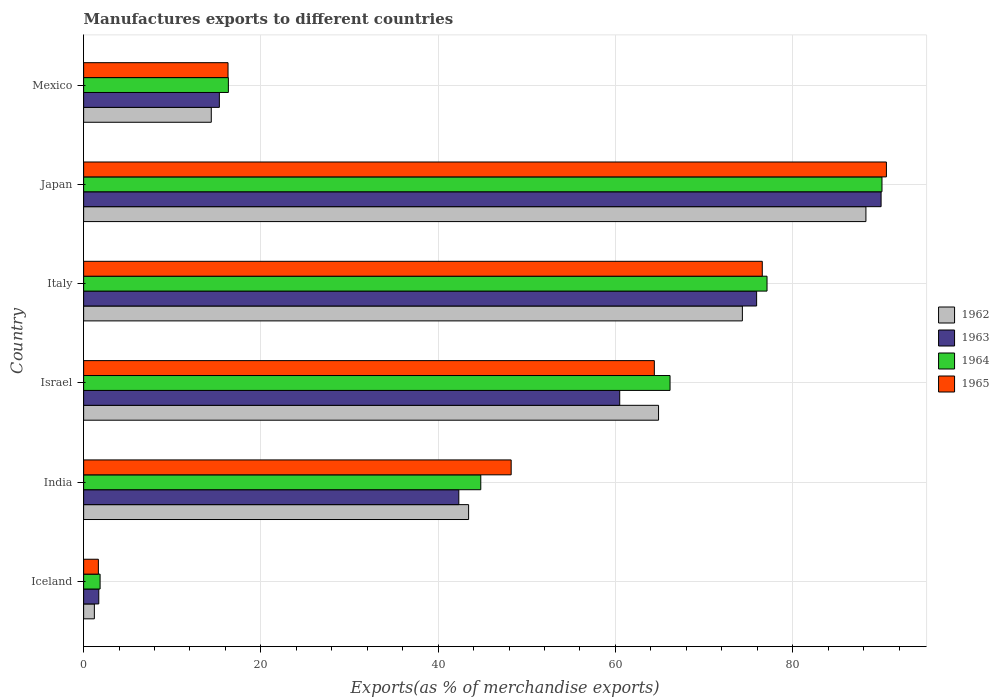How many bars are there on the 6th tick from the top?
Offer a very short reply. 4. How many bars are there on the 4th tick from the bottom?
Keep it short and to the point. 4. What is the label of the 4th group of bars from the top?
Your response must be concise. Israel. What is the percentage of exports to different countries in 1962 in Mexico?
Make the answer very short. 14.4. Across all countries, what is the maximum percentage of exports to different countries in 1964?
Give a very brief answer. 90.07. Across all countries, what is the minimum percentage of exports to different countries in 1962?
Keep it short and to the point. 1.21. In which country was the percentage of exports to different countries in 1962 maximum?
Offer a very short reply. Japan. In which country was the percentage of exports to different countries in 1965 minimum?
Your response must be concise. Iceland. What is the total percentage of exports to different countries in 1963 in the graph?
Make the answer very short. 285.74. What is the difference between the percentage of exports to different countries in 1962 in India and that in Israel?
Provide a succinct answer. -21.43. What is the difference between the percentage of exports to different countries in 1965 in Iceland and the percentage of exports to different countries in 1964 in Israel?
Offer a terse response. -64.5. What is the average percentage of exports to different countries in 1962 per country?
Offer a very short reply. 47.75. What is the difference between the percentage of exports to different countries in 1963 and percentage of exports to different countries in 1965 in Mexico?
Keep it short and to the point. -0.98. In how many countries, is the percentage of exports to different countries in 1964 greater than 44 %?
Your answer should be compact. 4. What is the ratio of the percentage of exports to different countries in 1963 in Italy to that in Japan?
Your response must be concise. 0.84. Is the percentage of exports to different countries in 1963 in Israel less than that in Italy?
Offer a very short reply. Yes. What is the difference between the highest and the second highest percentage of exports to different countries in 1962?
Provide a succinct answer. 13.94. What is the difference between the highest and the lowest percentage of exports to different countries in 1965?
Give a very brief answer. 88.91. In how many countries, is the percentage of exports to different countries in 1962 greater than the average percentage of exports to different countries in 1962 taken over all countries?
Ensure brevity in your answer.  3. What does the 3rd bar from the top in India represents?
Give a very brief answer. 1963. What does the 1st bar from the bottom in India represents?
Your response must be concise. 1962. Is it the case that in every country, the sum of the percentage of exports to different countries in 1965 and percentage of exports to different countries in 1964 is greater than the percentage of exports to different countries in 1962?
Your answer should be very brief. Yes. Are all the bars in the graph horizontal?
Provide a succinct answer. Yes. How many countries are there in the graph?
Provide a short and direct response. 6. What is the title of the graph?
Your response must be concise. Manufactures exports to different countries. Does "1964" appear as one of the legend labels in the graph?
Give a very brief answer. Yes. What is the label or title of the X-axis?
Provide a short and direct response. Exports(as % of merchandise exports). What is the label or title of the Y-axis?
Offer a very short reply. Country. What is the Exports(as % of merchandise exports) in 1962 in Iceland?
Give a very brief answer. 1.21. What is the Exports(as % of merchandise exports) in 1963 in Iceland?
Your answer should be very brief. 1.71. What is the Exports(as % of merchandise exports) of 1964 in Iceland?
Your answer should be compact. 1.86. What is the Exports(as % of merchandise exports) of 1965 in Iceland?
Offer a terse response. 1.66. What is the Exports(as % of merchandise exports) of 1962 in India?
Make the answer very short. 43.43. What is the Exports(as % of merchandise exports) in 1963 in India?
Give a very brief answer. 42.33. What is the Exports(as % of merchandise exports) of 1964 in India?
Make the answer very short. 44.81. What is the Exports(as % of merchandise exports) of 1965 in India?
Provide a succinct answer. 48.24. What is the Exports(as % of merchandise exports) in 1962 in Israel?
Provide a succinct answer. 64.86. What is the Exports(as % of merchandise exports) of 1963 in Israel?
Provide a short and direct response. 60.48. What is the Exports(as % of merchandise exports) of 1964 in Israel?
Make the answer very short. 66.16. What is the Exports(as % of merchandise exports) of 1965 in Israel?
Your answer should be very brief. 64.39. What is the Exports(as % of merchandise exports) in 1962 in Italy?
Your answer should be very brief. 74.32. What is the Exports(as % of merchandise exports) of 1963 in Italy?
Offer a very short reply. 75.93. What is the Exports(as % of merchandise exports) in 1964 in Italy?
Your response must be concise. 77.1. What is the Exports(as % of merchandise exports) of 1965 in Italy?
Your answer should be very brief. 76.57. What is the Exports(as % of merchandise exports) in 1962 in Japan?
Offer a terse response. 88.26. What is the Exports(as % of merchandise exports) of 1963 in Japan?
Provide a succinct answer. 89.97. What is the Exports(as % of merchandise exports) in 1964 in Japan?
Give a very brief answer. 90.07. What is the Exports(as % of merchandise exports) in 1965 in Japan?
Make the answer very short. 90.57. What is the Exports(as % of merchandise exports) in 1962 in Mexico?
Ensure brevity in your answer.  14.4. What is the Exports(as % of merchandise exports) in 1963 in Mexico?
Ensure brevity in your answer.  15.31. What is the Exports(as % of merchandise exports) in 1964 in Mexico?
Ensure brevity in your answer.  16.33. What is the Exports(as % of merchandise exports) in 1965 in Mexico?
Provide a succinct answer. 16.29. Across all countries, what is the maximum Exports(as % of merchandise exports) of 1962?
Your response must be concise. 88.26. Across all countries, what is the maximum Exports(as % of merchandise exports) in 1963?
Your response must be concise. 89.97. Across all countries, what is the maximum Exports(as % of merchandise exports) of 1964?
Give a very brief answer. 90.07. Across all countries, what is the maximum Exports(as % of merchandise exports) of 1965?
Keep it short and to the point. 90.57. Across all countries, what is the minimum Exports(as % of merchandise exports) of 1962?
Offer a very short reply. 1.21. Across all countries, what is the minimum Exports(as % of merchandise exports) in 1963?
Provide a succinct answer. 1.71. Across all countries, what is the minimum Exports(as % of merchandise exports) of 1964?
Make the answer very short. 1.86. Across all countries, what is the minimum Exports(as % of merchandise exports) in 1965?
Your answer should be compact. 1.66. What is the total Exports(as % of merchandise exports) of 1962 in the graph?
Your answer should be compact. 286.49. What is the total Exports(as % of merchandise exports) in 1963 in the graph?
Provide a short and direct response. 285.74. What is the total Exports(as % of merchandise exports) in 1964 in the graph?
Give a very brief answer. 296.33. What is the total Exports(as % of merchandise exports) of 1965 in the graph?
Your response must be concise. 297.72. What is the difference between the Exports(as % of merchandise exports) in 1962 in Iceland and that in India?
Keep it short and to the point. -42.22. What is the difference between the Exports(as % of merchandise exports) in 1963 in Iceland and that in India?
Your answer should be compact. -40.62. What is the difference between the Exports(as % of merchandise exports) in 1964 in Iceland and that in India?
Offer a very short reply. -42.95. What is the difference between the Exports(as % of merchandise exports) of 1965 in Iceland and that in India?
Your answer should be compact. -46.57. What is the difference between the Exports(as % of merchandise exports) of 1962 in Iceland and that in Israel?
Your response must be concise. -63.65. What is the difference between the Exports(as % of merchandise exports) in 1963 in Iceland and that in Israel?
Keep it short and to the point. -58.77. What is the difference between the Exports(as % of merchandise exports) of 1964 in Iceland and that in Israel?
Make the answer very short. -64.3. What is the difference between the Exports(as % of merchandise exports) in 1965 in Iceland and that in Israel?
Give a very brief answer. -62.73. What is the difference between the Exports(as % of merchandise exports) in 1962 in Iceland and that in Italy?
Offer a very short reply. -73.11. What is the difference between the Exports(as % of merchandise exports) in 1963 in Iceland and that in Italy?
Offer a terse response. -74.22. What is the difference between the Exports(as % of merchandise exports) of 1964 in Iceland and that in Italy?
Offer a terse response. -75.25. What is the difference between the Exports(as % of merchandise exports) of 1965 in Iceland and that in Italy?
Keep it short and to the point. -74.9. What is the difference between the Exports(as % of merchandise exports) of 1962 in Iceland and that in Japan?
Give a very brief answer. -87.05. What is the difference between the Exports(as % of merchandise exports) in 1963 in Iceland and that in Japan?
Give a very brief answer. -88.26. What is the difference between the Exports(as % of merchandise exports) in 1964 in Iceland and that in Japan?
Your answer should be very brief. -88.22. What is the difference between the Exports(as % of merchandise exports) of 1965 in Iceland and that in Japan?
Offer a terse response. -88.91. What is the difference between the Exports(as % of merchandise exports) in 1962 in Iceland and that in Mexico?
Keep it short and to the point. -13.19. What is the difference between the Exports(as % of merchandise exports) in 1963 in Iceland and that in Mexico?
Ensure brevity in your answer.  -13.6. What is the difference between the Exports(as % of merchandise exports) of 1964 in Iceland and that in Mexico?
Give a very brief answer. -14.47. What is the difference between the Exports(as % of merchandise exports) in 1965 in Iceland and that in Mexico?
Make the answer very short. -14.63. What is the difference between the Exports(as % of merchandise exports) in 1962 in India and that in Israel?
Your response must be concise. -21.43. What is the difference between the Exports(as % of merchandise exports) in 1963 in India and that in Israel?
Your answer should be very brief. -18.15. What is the difference between the Exports(as % of merchandise exports) in 1964 in India and that in Israel?
Make the answer very short. -21.35. What is the difference between the Exports(as % of merchandise exports) in 1965 in India and that in Israel?
Your answer should be compact. -16.15. What is the difference between the Exports(as % of merchandise exports) in 1962 in India and that in Italy?
Ensure brevity in your answer.  -30.89. What is the difference between the Exports(as % of merchandise exports) in 1963 in India and that in Italy?
Make the answer very short. -33.6. What is the difference between the Exports(as % of merchandise exports) of 1964 in India and that in Italy?
Your answer should be compact. -32.3. What is the difference between the Exports(as % of merchandise exports) of 1965 in India and that in Italy?
Give a very brief answer. -28.33. What is the difference between the Exports(as % of merchandise exports) in 1962 in India and that in Japan?
Your answer should be compact. -44.83. What is the difference between the Exports(as % of merchandise exports) of 1963 in India and that in Japan?
Give a very brief answer. -47.64. What is the difference between the Exports(as % of merchandise exports) of 1964 in India and that in Japan?
Give a very brief answer. -45.26. What is the difference between the Exports(as % of merchandise exports) in 1965 in India and that in Japan?
Keep it short and to the point. -42.34. What is the difference between the Exports(as % of merchandise exports) in 1962 in India and that in Mexico?
Give a very brief answer. 29.03. What is the difference between the Exports(as % of merchandise exports) of 1963 in India and that in Mexico?
Offer a very short reply. 27.01. What is the difference between the Exports(as % of merchandise exports) in 1964 in India and that in Mexico?
Make the answer very short. 28.48. What is the difference between the Exports(as % of merchandise exports) in 1965 in India and that in Mexico?
Keep it short and to the point. 31.95. What is the difference between the Exports(as % of merchandise exports) in 1962 in Israel and that in Italy?
Your answer should be compact. -9.46. What is the difference between the Exports(as % of merchandise exports) of 1963 in Israel and that in Italy?
Keep it short and to the point. -15.45. What is the difference between the Exports(as % of merchandise exports) of 1964 in Israel and that in Italy?
Keep it short and to the point. -10.94. What is the difference between the Exports(as % of merchandise exports) in 1965 in Israel and that in Italy?
Give a very brief answer. -12.18. What is the difference between the Exports(as % of merchandise exports) in 1962 in Israel and that in Japan?
Your answer should be compact. -23.4. What is the difference between the Exports(as % of merchandise exports) of 1963 in Israel and that in Japan?
Ensure brevity in your answer.  -29.49. What is the difference between the Exports(as % of merchandise exports) of 1964 in Israel and that in Japan?
Provide a succinct answer. -23.91. What is the difference between the Exports(as % of merchandise exports) in 1965 in Israel and that in Japan?
Make the answer very short. -26.18. What is the difference between the Exports(as % of merchandise exports) in 1962 in Israel and that in Mexico?
Keep it short and to the point. 50.46. What is the difference between the Exports(as % of merchandise exports) of 1963 in Israel and that in Mexico?
Give a very brief answer. 45.17. What is the difference between the Exports(as % of merchandise exports) of 1964 in Israel and that in Mexico?
Your answer should be compact. 49.83. What is the difference between the Exports(as % of merchandise exports) of 1965 in Israel and that in Mexico?
Ensure brevity in your answer.  48.1. What is the difference between the Exports(as % of merchandise exports) of 1962 in Italy and that in Japan?
Your answer should be very brief. -13.94. What is the difference between the Exports(as % of merchandise exports) of 1963 in Italy and that in Japan?
Give a very brief answer. -14.04. What is the difference between the Exports(as % of merchandise exports) in 1964 in Italy and that in Japan?
Provide a short and direct response. -12.97. What is the difference between the Exports(as % of merchandise exports) in 1965 in Italy and that in Japan?
Your answer should be very brief. -14.01. What is the difference between the Exports(as % of merchandise exports) in 1962 in Italy and that in Mexico?
Offer a very short reply. 59.92. What is the difference between the Exports(as % of merchandise exports) of 1963 in Italy and that in Mexico?
Your response must be concise. 60.61. What is the difference between the Exports(as % of merchandise exports) in 1964 in Italy and that in Mexico?
Your response must be concise. 60.77. What is the difference between the Exports(as % of merchandise exports) in 1965 in Italy and that in Mexico?
Provide a succinct answer. 60.28. What is the difference between the Exports(as % of merchandise exports) in 1962 in Japan and that in Mexico?
Your response must be concise. 73.86. What is the difference between the Exports(as % of merchandise exports) of 1963 in Japan and that in Mexico?
Your response must be concise. 74.66. What is the difference between the Exports(as % of merchandise exports) of 1964 in Japan and that in Mexico?
Offer a very short reply. 73.74. What is the difference between the Exports(as % of merchandise exports) of 1965 in Japan and that in Mexico?
Your response must be concise. 74.28. What is the difference between the Exports(as % of merchandise exports) in 1962 in Iceland and the Exports(as % of merchandise exports) in 1963 in India?
Offer a very short reply. -41.12. What is the difference between the Exports(as % of merchandise exports) in 1962 in Iceland and the Exports(as % of merchandise exports) in 1964 in India?
Offer a terse response. -43.6. What is the difference between the Exports(as % of merchandise exports) of 1962 in Iceland and the Exports(as % of merchandise exports) of 1965 in India?
Provide a short and direct response. -47.03. What is the difference between the Exports(as % of merchandise exports) of 1963 in Iceland and the Exports(as % of merchandise exports) of 1964 in India?
Offer a terse response. -43.1. What is the difference between the Exports(as % of merchandise exports) of 1963 in Iceland and the Exports(as % of merchandise exports) of 1965 in India?
Your answer should be very brief. -46.53. What is the difference between the Exports(as % of merchandise exports) in 1964 in Iceland and the Exports(as % of merchandise exports) in 1965 in India?
Your answer should be compact. -46.38. What is the difference between the Exports(as % of merchandise exports) in 1962 in Iceland and the Exports(as % of merchandise exports) in 1963 in Israel?
Ensure brevity in your answer.  -59.27. What is the difference between the Exports(as % of merchandise exports) of 1962 in Iceland and the Exports(as % of merchandise exports) of 1964 in Israel?
Your response must be concise. -64.95. What is the difference between the Exports(as % of merchandise exports) of 1962 in Iceland and the Exports(as % of merchandise exports) of 1965 in Israel?
Make the answer very short. -63.18. What is the difference between the Exports(as % of merchandise exports) of 1963 in Iceland and the Exports(as % of merchandise exports) of 1964 in Israel?
Your answer should be compact. -64.45. What is the difference between the Exports(as % of merchandise exports) in 1963 in Iceland and the Exports(as % of merchandise exports) in 1965 in Israel?
Keep it short and to the point. -62.68. What is the difference between the Exports(as % of merchandise exports) in 1964 in Iceland and the Exports(as % of merchandise exports) in 1965 in Israel?
Ensure brevity in your answer.  -62.53. What is the difference between the Exports(as % of merchandise exports) of 1962 in Iceland and the Exports(as % of merchandise exports) of 1963 in Italy?
Keep it short and to the point. -74.72. What is the difference between the Exports(as % of merchandise exports) of 1962 in Iceland and the Exports(as % of merchandise exports) of 1964 in Italy?
Your answer should be very brief. -75.89. What is the difference between the Exports(as % of merchandise exports) in 1962 in Iceland and the Exports(as % of merchandise exports) in 1965 in Italy?
Keep it short and to the point. -75.36. What is the difference between the Exports(as % of merchandise exports) in 1963 in Iceland and the Exports(as % of merchandise exports) in 1964 in Italy?
Ensure brevity in your answer.  -75.39. What is the difference between the Exports(as % of merchandise exports) in 1963 in Iceland and the Exports(as % of merchandise exports) in 1965 in Italy?
Provide a succinct answer. -74.86. What is the difference between the Exports(as % of merchandise exports) of 1964 in Iceland and the Exports(as % of merchandise exports) of 1965 in Italy?
Provide a succinct answer. -74.71. What is the difference between the Exports(as % of merchandise exports) in 1962 in Iceland and the Exports(as % of merchandise exports) in 1963 in Japan?
Offer a very short reply. -88.76. What is the difference between the Exports(as % of merchandise exports) in 1962 in Iceland and the Exports(as % of merchandise exports) in 1964 in Japan?
Your answer should be very brief. -88.86. What is the difference between the Exports(as % of merchandise exports) of 1962 in Iceland and the Exports(as % of merchandise exports) of 1965 in Japan?
Offer a very short reply. -89.36. What is the difference between the Exports(as % of merchandise exports) in 1963 in Iceland and the Exports(as % of merchandise exports) in 1964 in Japan?
Provide a short and direct response. -88.36. What is the difference between the Exports(as % of merchandise exports) of 1963 in Iceland and the Exports(as % of merchandise exports) of 1965 in Japan?
Ensure brevity in your answer.  -88.86. What is the difference between the Exports(as % of merchandise exports) of 1964 in Iceland and the Exports(as % of merchandise exports) of 1965 in Japan?
Your answer should be compact. -88.72. What is the difference between the Exports(as % of merchandise exports) in 1962 in Iceland and the Exports(as % of merchandise exports) in 1963 in Mexico?
Ensure brevity in your answer.  -14.1. What is the difference between the Exports(as % of merchandise exports) in 1962 in Iceland and the Exports(as % of merchandise exports) in 1964 in Mexico?
Ensure brevity in your answer.  -15.12. What is the difference between the Exports(as % of merchandise exports) of 1962 in Iceland and the Exports(as % of merchandise exports) of 1965 in Mexico?
Provide a short and direct response. -15.08. What is the difference between the Exports(as % of merchandise exports) in 1963 in Iceland and the Exports(as % of merchandise exports) in 1964 in Mexico?
Provide a succinct answer. -14.62. What is the difference between the Exports(as % of merchandise exports) in 1963 in Iceland and the Exports(as % of merchandise exports) in 1965 in Mexico?
Your answer should be very brief. -14.58. What is the difference between the Exports(as % of merchandise exports) in 1964 in Iceland and the Exports(as % of merchandise exports) in 1965 in Mexico?
Provide a succinct answer. -14.43. What is the difference between the Exports(as % of merchandise exports) of 1962 in India and the Exports(as % of merchandise exports) of 1963 in Israel?
Your answer should be very brief. -17.05. What is the difference between the Exports(as % of merchandise exports) in 1962 in India and the Exports(as % of merchandise exports) in 1964 in Israel?
Keep it short and to the point. -22.73. What is the difference between the Exports(as % of merchandise exports) in 1962 in India and the Exports(as % of merchandise exports) in 1965 in Israel?
Ensure brevity in your answer.  -20.96. What is the difference between the Exports(as % of merchandise exports) of 1963 in India and the Exports(as % of merchandise exports) of 1964 in Israel?
Ensure brevity in your answer.  -23.83. What is the difference between the Exports(as % of merchandise exports) in 1963 in India and the Exports(as % of merchandise exports) in 1965 in Israel?
Ensure brevity in your answer.  -22.06. What is the difference between the Exports(as % of merchandise exports) of 1964 in India and the Exports(as % of merchandise exports) of 1965 in Israel?
Ensure brevity in your answer.  -19.58. What is the difference between the Exports(as % of merchandise exports) in 1962 in India and the Exports(as % of merchandise exports) in 1963 in Italy?
Ensure brevity in your answer.  -32.49. What is the difference between the Exports(as % of merchandise exports) of 1962 in India and the Exports(as % of merchandise exports) of 1964 in Italy?
Make the answer very short. -33.67. What is the difference between the Exports(as % of merchandise exports) in 1962 in India and the Exports(as % of merchandise exports) in 1965 in Italy?
Offer a very short reply. -33.13. What is the difference between the Exports(as % of merchandise exports) of 1963 in India and the Exports(as % of merchandise exports) of 1964 in Italy?
Give a very brief answer. -34.77. What is the difference between the Exports(as % of merchandise exports) of 1963 in India and the Exports(as % of merchandise exports) of 1965 in Italy?
Offer a very short reply. -34.24. What is the difference between the Exports(as % of merchandise exports) of 1964 in India and the Exports(as % of merchandise exports) of 1965 in Italy?
Your answer should be compact. -31.76. What is the difference between the Exports(as % of merchandise exports) in 1962 in India and the Exports(as % of merchandise exports) in 1963 in Japan?
Offer a terse response. -46.54. What is the difference between the Exports(as % of merchandise exports) of 1962 in India and the Exports(as % of merchandise exports) of 1964 in Japan?
Make the answer very short. -46.64. What is the difference between the Exports(as % of merchandise exports) in 1962 in India and the Exports(as % of merchandise exports) in 1965 in Japan?
Give a very brief answer. -47.14. What is the difference between the Exports(as % of merchandise exports) of 1963 in India and the Exports(as % of merchandise exports) of 1964 in Japan?
Make the answer very short. -47.74. What is the difference between the Exports(as % of merchandise exports) of 1963 in India and the Exports(as % of merchandise exports) of 1965 in Japan?
Offer a terse response. -48.24. What is the difference between the Exports(as % of merchandise exports) of 1964 in India and the Exports(as % of merchandise exports) of 1965 in Japan?
Your answer should be very brief. -45.76. What is the difference between the Exports(as % of merchandise exports) in 1962 in India and the Exports(as % of merchandise exports) in 1963 in Mexico?
Provide a short and direct response. 28.12. What is the difference between the Exports(as % of merchandise exports) in 1962 in India and the Exports(as % of merchandise exports) in 1964 in Mexico?
Ensure brevity in your answer.  27.1. What is the difference between the Exports(as % of merchandise exports) of 1962 in India and the Exports(as % of merchandise exports) of 1965 in Mexico?
Your answer should be compact. 27.14. What is the difference between the Exports(as % of merchandise exports) of 1963 in India and the Exports(as % of merchandise exports) of 1964 in Mexico?
Offer a terse response. 26. What is the difference between the Exports(as % of merchandise exports) in 1963 in India and the Exports(as % of merchandise exports) in 1965 in Mexico?
Keep it short and to the point. 26.04. What is the difference between the Exports(as % of merchandise exports) of 1964 in India and the Exports(as % of merchandise exports) of 1965 in Mexico?
Your answer should be very brief. 28.52. What is the difference between the Exports(as % of merchandise exports) of 1962 in Israel and the Exports(as % of merchandise exports) of 1963 in Italy?
Provide a short and direct response. -11.07. What is the difference between the Exports(as % of merchandise exports) in 1962 in Israel and the Exports(as % of merchandise exports) in 1964 in Italy?
Offer a terse response. -12.24. What is the difference between the Exports(as % of merchandise exports) in 1962 in Israel and the Exports(as % of merchandise exports) in 1965 in Italy?
Make the answer very short. -11.7. What is the difference between the Exports(as % of merchandise exports) in 1963 in Israel and the Exports(as % of merchandise exports) in 1964 in Italy?
Keep it short and to the point. -16.62. What is the difference between the Exports(as % of merchandise exports) of 1963 in Israel and the Exports(as % of merchandise exports) of 1965 in Italy?
Offer a terse response. -16.08. What is the difference between the Exports(as % of merchandise exports) in 1964 in Israel and the Exports(as % of merchandise exports) in 1965 in Italy?
Your answer should be compact. -10.41. What is the difference between the Exports(as % of merchandise exports) of 1962 in Israel and the Exports(as % of merchandise exports) of 1963 in Japan?
Give a very brief answer. -25.11. What is the difference between the Exports(as % of merchandise exports) in 1962 in Israel and the Exports(as % of merchandise exports) in 1964 in Japan?
Give a very brief answer. -25.21. What is the difference between the Exports(as % of merchandise exports) in 1962 in Israel and the Exports(as % of merchandise exports) in 1965 in Japan?
Ensure brevity in your answer.  -25.71. What is the difference between the Exports(as % of merchandise exports) of 1963 in Israel and the Exports(as % of merchandise exports) of 1964 in Japan?
Your answer should be very brief. -29.59. What is the difference between the Exports(as % of merchandise exports) in 1963 in Israel and the Exports(as % of merchandise exports) in 1965 in Japan?
Offer a very short reply. -30.09. What is the difference between the Exports(as % of merchandise exports) of 1964 in Israel and the Exports(as % of merchandise exports) of 1965 in Japan?
Your answer should be very brief. -24.41. What is the difference between the Exports(as % of merchandise exports) in 1962 in Israel and the Exports(as % of merchandise exports) in 1963 in Mexico?
Your answer should be compact. 49.55. What is the difference between the Exports(as % of merchandise exports) of 1962 in Israel and the Exports(as % of merchandise exports) of 1964 in Mexico?
Ensure brevity in your answer.  48.53. What is the difference between the Exports(as % of merchandise exports) of 1962 in Israel and the Exports(as % of merchandise exports) of 1965 in Mexico?
Give a very brief answer. 48.57. What is the difference between the Exports(as % of merchandise exports) in 1963 in Israel and the Exports(as % of merchandise exports) in 1964 in Mexico?
Your response must be concise. 44.15. What is the difference between the Exports(as % of merchandise exports) in 1963 in Israel and the Exports(as % of merchandise exports) in 1965 in Mexico?
Give a very brief answer. 44.19. What is the difference between the Exports(as % of merchandise exports) of 1964 in Israel and the Exports(as % of merchandise exports) of 1965 in Mexico?
Your answer should be very brief. 49.87. What is the difference between the Exports(as % of merchandise exports) in 1962 in Italy and the Exports(as % of merchandise exports) in 1963 in Japan?
Offer a terse response. -15.65. What is the difference between the Exports(as % of merchandise exports) in 1962 in Italy and the Exports(as % of merchandise exports) in 1964 in Japan?
Your response must be concise. -15.75. What is the difference between the Exports(as % of merchandise exports) of 1962 in Italy and the Exports(as % of merchandise exports) of 1965 in Japan?
Make the answer very short. -16.25. What is the difference between the Exports(as % of merchandise exports) in 1963 in Italy and the Exports(as % of merchandise exports) in 1964 in Japan?
Your response must be concise. -14.14. What is the difference between the Exports(as % of merchandise exports) of 1963 in Italy and the Exports(as % of merchandise exports) of 1965 in Japan?
Make the answer very short. -14.64. What is the difference between the Exports(as % of merchandise exports) of 1964 in Italy and the Exports(as % of merchandise exports) of 1965 in Japan?
Your response must be concise. -13.47. What is the difference between the Exports(as % of merchandise exports) of 1962 in Italy and the Exports(as % of merchandise exports) of 1963 in Mexico?
Your answer should be very brief. 59.01. What is the difference between the Exports(as % of merchandise exports) of 1962 in Italy and the Exports(as % of merchandise exports) of 1964 in Mexico?
Your answer should be compact. 57.99. What is the difference between the Exports(as % of merchandise exports) of 1962 in Italy and the Exports(as % of merchandise exports) of 1965 in Mexico?
Your answer should be very brief. 58.03. What is the difference between the Exports(as % of merchandise exports) in 1963 in Italy and the Exports(as % of merchandise exports) in 1964 in Mexico?
Offer a terse response. 59.6. What is the difference between the Exports(as % of merchandise exports) in 1963 in Italy and the Exports(as % of merchandise exports) in 1965 in Mexico?
Make the answer very short. 59.64. What is the difference between the Exports(as % of merchandise exports) of 1964 in Italy and the Exports(as % of merchandise exports) of 1965 in Mexico?
Ensure brevity in your answer.  60.81. What is the difference between the Exports(as % of merchandise exports) in 1962 in Japan and the Exports(as % of merchandise exports) in 1963 in Mexico?
Make the answer very short. 72.95. What is the difference between the Exports(as % of merchandise exports) in 1962 in Japan and the Exports(as % of merchandise exports) in 1964 in Mexico?
Offer a very short reply. 71.93. What is the difference between the Exports(as % of merchandise exports) of 1962 in Japan and the Exports(as % of merchandise exports) of 1965 in Mexico?
Provide a succinct answer. 71.97. What is the difference between the Exports(as % of merchandise exports) of 1963 in Japan and the Exports(as % of merchandise exports) of 1964 in Mexico?
Provide a succinct answer. 73.64. What is the difference between the Exports(as % of merchandise exports) in 1963 in Japan and the Exports(as % of merchandise exports) in 1965 in Mexico?
Provide a short and direct response. 73.68. What is the difference between the Exports(as % of merchandise exports) in 1964 in Japan and the Exports(as % of merchandise exports) in 1965 in Mexico?
Keep it short and to the point. 73.78. What is the average Exports(as % of merchandise exports) of 1962 per country?
Make the answer very short. 47.75. What is the average Exports(as % of merchandise exports) in 1963 per country?
Give a very brief answer. 47.62. What is the average Exports(as % of merchandise exports) in 1964 per country?
Your answer should be compact. 49.39. What is the average Exports(as % of merchandise exports) of 1965 per country?
Offer a terse response. 49.62. What is the difference between the Exports(as % of merchandise exports) in 1962 and Exports(as % of merchandise exports) in 1964 in Iceland?
Your response must be concise. -0.65. What is the difference between the Exports(as % of merchandise exports) of 1962 and Exports(as % of merchandise exports) of 1965 in Iceland?
Your answer should be very brief. -0.45. What is the difference between the Exports(as % of merchandise exports) in 1963 and Exports(as % of merchandise exports) in 1964 in Iceland?
Keep it short and to the point. -0.15. What is the difference between the Exports(as % of merchandise exports) of 1963 and Exports(as % of merchandise exports) of 1965 in Iceland?
Make the answer very short. 0.05. What is the difference between the Exports(as % of merchandise exports) in 1964 and Exports(as % of merchandise exports) in 1965 in Iceland?
Make the answer very short. 0.19. What is the difference between the Exports(as % of merchandise exports) of 1962 and Exports(as % of merchandise exports) of 1963 in India?
Your answer should be very brief. 1.11. What is the difference between the Exports(as % of merchandise exports) in 1962 and Exports(as % of merchandise exports) in 1964 in India?
Your response must be concise. -1.37. What is the difference between the Exports(as % of merchandise exports) of 1962 and Exports(as % of merchandise exports) of 1965 in India?
Your answer should be compact. -4.8. What is the difference between the Exports(as % of merchandise exports) in 1963 and Exports(as % of merchandise exports) in 1964 in India?
Make the answer very short. -2.48. What is the difference between the Exports(as % of merchandise exports) in 1963 and Exports(as % of merchandise exports) in 1965 in India?
Your response must be concise. -5.91. What is the difference between the Exports(as % of merchandise exports) in 1964 and Exports(as % of merchandise exports) in 1965 in India?
Give a very brief answer. -3.43. What is the difference between the Exports(as % of merchandise exports) of 1962 and Exports(as % of merchandise exports) of 1963 in Israel?
Your answer should be compact. 4.38. What is the difference between the Exports(as % of merchandise exports) in 1962 and Exports(as % of merchandise exports) in 1964 in Israel?
Your answer should be compact. -1.3. What is the difference between the Exports(as % of merchandise exports) of 1962 and Exports(as % of merchandise exports) of 1965 in Israel?
Provide a short and direct response. 0.47. What is the difference between the Exports(as % of merchandise exports) of 1963 and Exports(as % of merchandise exports) of 1964 in Israel?
Your answer should be compact. -5.68. What is the difference between the Exports(as % of merchandise exports) of 1963 and Exports(as % of merchandise exports) of 1965 in Israel?
Your answer should be compact. -3.91. What is the difference between the Exports(as % of merchandise exports) of 1964 and Exports(as % of merchandise exports) of 1965 in Israel?
Offer a very short reply. 1.77. What is the difference between the Exports(as % of merchandise exports) of 1962 and Exports(as % of merchandise exports) of 1963 in Italy?
Offer a very short reply. -1.61. What is the difference between the Exports(as % of merchandise exports) in 1962 and Exports(as % of merchandise exports) in 1964 in Italy?
Your answer should be compact. -2.78. What is the difference between the Exports(as % of merchandise exports) of 1962 and Exports(as % of merchandise exports) of 1965 in Italy?
Your response must be concise. -2.25. What is the difference between the Exports(as % of merchandise exports) of 1963 and Exports(as % of merchandise exports) of 1964 in Italy?
Your answer should be very brief. -1.17. What is the difference between the Exports(as % of merchandise exports) in 1963 and Exports(as % of merchandise exports) in 1965 in Italy?
Offer a terse response. -0.64. What is the difference between the Exports(as % of merchandise exports) in 1964 and Exports(as % of merchandise exports) in 1965 in Italy?
Offer a very short reply. 0.54. What is the difference between the Exports(as % of merchandise exports) of 1962 and Exports(as % of merchandise exports) of 1963 in Japan?
Ensure brevity in your answer.  -1.71. What is the difference between the Exports(as % of merchandise exports) in 1962 and Exports(as % of merchandise exports) in 1964 in Japan?
Your answer should be compact. -1.81. What is the difference between the Exports(as % of merchandise exports) in 1962 and Exports(as % of merchandise exports) in 1965 in Japan?
Your answer should be compact. -2.31. What is the difference between the Exports(as % of merchandise exports) in 1963 and Exports(as % of merchandise exports) in 1964 in Japan?
Your answer should be compact. -0.1. What is the difference between the Exports(as % of merchandise exports) of 1963 and Exports(as % of merchandise exports) of 1965 in Japan?
Provide a succinct answer. -0.6. What is the difference between the Exports(as % of merchandise exports) in 1964 and Exports(as % of merchandise exports) in 1965 in Japan?
Provide a short and direct response. -0.5. What is the difference between the Exports(as % of merchandise exports) in 1962 and Exports(as % of merchandise exports) in 1963 in Mexico?
Ensure brevity in your answer.  -0.91. What is the difference between the Exports(as % of merchandise exports) in 1962 and Exports(as % of merchandise exports) in 1964 in Mexico?
Provide a short and direct response. -1.93. What is the difference between the Exports(as % of merchandise exports) in 1962 and Exports(as % of merchandise exports) in 1965 in Mexico?
Give a very brief answer. -1.89. What is the difference between the Exports(as % of merchandise exports) in 1963 and Exports(as % of merchandise exports) in 1964 in Mexico?
Your answer should be very brief. -1.02. What is the difference between the Exports(as % of merchandise exports) in 1963 and Exports(as % of merchandise exports) in 1965 in Mexico?
Give a very brief answer. -0.98. What is the difference between the Exports(as % of merchandise exports) in 1964 and Exports(as % of merchandise exports) in 1965 in Mexico?
Ensure brevity in your answer.  0.04. What is the ratio of the Exports(as % of merchandise exports) of 1962 in Iceland to that in India?
Make the answer very short. 0.03. What is the ratio of the Exports(as % of merchandise exports) in 1963 in Iceland to that in India?
Offer a terse response. 0.04. What is the ratio of the Exports(as % of merchandise exports) in 1964 in Iceland to that in India?
Your answer should be compact. 0.04. What is the ratio of the Exports(as % of merchandise exports) in 1965 in Iceland to that in India?
Offer a terse response. 0.03. What is the ratio of the Exports(as % of merchandise exports) in 1962 in Iceland to that in Israel?
Provide a short and direct response. 0.02. What is the ratio of the Exports(as % of merchandise exports) of 1963 in Iceland to that in Israel?
Ensure brevity in your answer.  0.03. What is the ratio of the Exports(as % of merchandise exports) in 1964 in Iceland to that in Israel?
Give a very brief answer. 0.03. What is the ratio of the Exports(as % of merchandise exports) in 1965 in Iceland to that in Israel?
Give a very brief answer. 0.03. What is the ratio of the Exports(as % of merchandise exports) of 1962 in Iceland to that in Italy?
Your answer should be compact. 0.02. What is the ratio of the Exports(as % of merchandise exports) of 1963 in Iceland to that in Italy?
Keep it short and to the point. 0.02. What is the ratio of the Exports(as % of merchandise exports) in 1964 in Iceland to that in Italy?
Your response must be concise. 0.02. What is the ratio of the Exports(as % of merchandise exports) in 1965 in Iceland to that in Italy?
Offer a terse response. 0.02. What is the ratio of the Exports(as % of merchandise exports) of 1962 in Iceland to that in Japan?
Give a very brief answer. 0.01. What is the ratio of the Exports(as % of merchandise exports) of 1963 in Iceland to that in Japan?
Provide a short and direct response. 0.02. What is the ratio of the Exports(as % of merchandise exports) of 1964 in Iceland to that in Japan?
Keep it short and to the point. 0.02. What is the ratio of the Exports(as % of merchandise exports) of 1965 in Iceland to that in Japan?
Make the answer very short. 0.02. What is the ratio of the Exports(as % of merchandise exports) of 1962 in Iceland to that in Mexico?
Offer a terse response. 0.08. What is the ratio of the Exports(as % of merchandise exports) of 1963 in Iceland to that in Mexico?
Offer a very short reply. 0.11. What is the ratio of the Exports(as % of merchandise exports) of 1964 in Iceland to that in Mexico?
Provide a short and direct response. 0.11. What is the ratio of the Exports(as % of merchandise exports) in 1965 in Iceland to that in Mexico?
Keep it short and to the point. 0.1. What is the ratio of the Exports(as % of merchandise exports) of 1962 in India to that in Israel?
Your answer should be compact. 0.67. What is the ratio of the Exports(as % of merchandise exports) in 1963 in India to that in Israel?
Ensure brevity in your answer.  0.7. What is the ratio of the Exports(as % of merchandise exports) in 1964 in India to that in Israel?
Your response must be concise. 0.68. What is the ratio of the Exports(as % of merchandise exports) in 1965 in India to that in Israel?
Offer a terse response. 0.75. What is the ratio of the Exports(as % of merchandise exports) of 1962 in India to that in Italy?
Offer a terse response. 0.58. What is the ratio of the Exports(as % of merchandise exports) in 1963 in India to that in Italy?
Keep it short and to the point. 0.56. What is the ratio of the Exports(as % of merchandise exports) in 1964 in India to that in Italy?
Keep it short and to the point. 0.58. What is the ratio of the Exports(as % of merchandise exports) in 1965 in India to that in Italy?
Offer a terse response. 0.63. What is the ratio of the Exports(as % of merchandise exports) in 1962 in India to that in Japan?
Your answer should be very brief. 0.49. What is the ratio of the Exports(as % of merchandise exports) of 1963 in India to that in Japan?
Give a very brief answer. 0.47. What is the ratio of the Exports(as % of merchandise exports) in 1964 in India to that in Japan?
Your answer should be very brief. 0.5. What is the ratio of the Exports(as % of merchandise exports) of 1965 in India to that in Japan?
Keep it short and to the point. 0.53. What is the ratio of the Exports(as % of merchandise exports) in 1962 in India to that in Mexico?
Keep it short and to the point. 3.02. What is the ratio of the Exports(as % of merchandise exports) in 1963 in India to that in Mexico?
Your answer should be very brief. 2.76. What is the ratio of the Exports(as % of merchandise exports) in 1964 in India to that in Mexico?
Make the answer very short. 2.74. What is the ratio of the Exports(as % of merchandise exports) of 1965 in India to that in Mexico?
Provide a succinct answer. 2.96. What is the ratio of the Exports(as % of merchandise exports) in 1962 in Israel to that in Italy?
Offer a terse response. 0.87. What is the ratio of the Exports(as % of merchandise exports) in 1963 in Israel to that in Italy?
Ensure brevity in your answer.  0.8. What is the ratio of the Exports(as % of merchandise exports) of 1964 in Israel to that in Italy?
Offer a very short reply. 0.86. What is the ratio of the Exports(as % of merchandise exports) of 1965 in Israel to that in Italy?
Provide a short and direct response. 0.84. What is the ratio of the Exports(as % of merchandise exports) of 1962 in Israel to that in Japan?
Make the answer very short. 0.73. What is the ratio of the Exports(as % of merchandise exports) in 1963 in Israel to that in Japan?
Keep it short and to the point. 0.67. What is the ratio of the Exports(as % of merchandise exports) in 1964 in Israel to that in Japan?
Provide a short and direct response. 0.73. What is the ratio of the Exports(as % of merchandise exports) in 1965 in Israel to that in Japan?
Offer a terse response. 0.71. What is the ratio of the Exports(as % of merchandise exports) in 1962 in Israel to that in Mexico?
Your answer should be very brief. 4.5. What is the ratio of the Exports(as % of merchandise exports) of 1963 in Israel to that in Mexico?
Provide a short and direct response. 3.95. What is the ratio of the Exports(as % of merchandise exports) in 1964 in Israel to that in Mexico?
Keep it short and to the point. 4.05. What is the ratio of the Exports(as % of merchandise exports) in 1965 in Israel to that in Mexico?
Ensure brevity in your answer.  3.95. What is the ratio of the Exports(as % of merchandise exports) of 1962 in Italy to that in Japan?
Your response must be concise. 0.84. What is the ratio of the Exports(as % of merchandise exports) in 1963 in Italy to that in Japan?
Ensure brevity in your answer.  0.84. What is the ratio of the Exports(as % of merchandise exports) in 1964 in Italy to that in Japan?
Your response must be concise. 0.86. What is the ratio of the Exports(as % of merchandise exports) in 1965 in Italy to that in Japan?
Make the answer very short. 0.85. What is the ratio of the Exports(as % of merchandise exports) in 1962 in Italy to that in Mexico?
Your response must be concise. 5.16. What is the ratio of the Exports(as % of merchandise exports) in 1963 in Italy to that in Mexico?
Provide a short and direct response. 4.96. What is the ratio of the Exports(as % of merchandise exports) in 1964 in Italy to that in Mexico?
Make the answer very short. 4.72. What is the ratio of the Exports(as % of merchandise exports) of 1965 in Italy to that in Mexico?
Ensure brevity in your answer.  4.7. What is the ratio of the Exports(as % of merchandise exports) in 1962 in Japan to that in Mexico?
Keep it short and to the point. 6.13. What is the ratio of the Exports(as % of merchandise exports) in 1963 in Japan to that in Mexico?
Give a very brief answer. 5.88. What is the ratio of the Exports(as % of merchandise exports) in 1964 in Japan to that in Mexico?
Keep it short and to the point. 5.52. What is the ratio of the Exports(as % of merchandise exports) in 1965 in Japan to that in Mexico?
Your answer should be compact. 5.56. What is the difference between the highest and the second highest Exports(as % of merchandise exports) in 1962?
Your answer should be compact. 13.94. What is the difference between the highest and the second highest Exports(as % of merchandise exports) of 1963?
Make the answer very short. 14.04. What is the difference between the highest and the second highest Exports(as % of merchandise exports) in 1964?
Your answer should be very brief. 12.97. What is the difference between the highest and the second highest Exports(as % of merchandise exports) of 1965?
Make the answer very short. 14.01. What is the difference between the highest and the lowest Exports(as % of merchandise exports) of 1962?
Your answer should be compact. 87.05. What is the difference between the highest and the lowest Exports(as % of merchandise exports) in 1963?
Provide a succinct answer. 88.26. What is the difference between the highest and the lowest Exports(as % of merchandise exports) of 1964?
Provide a succinct answer. 88.22. What is the difference between the highest and the lowest Exports(as % of merchandise exports) of 1965?
Make the answer very short. 88.91. 